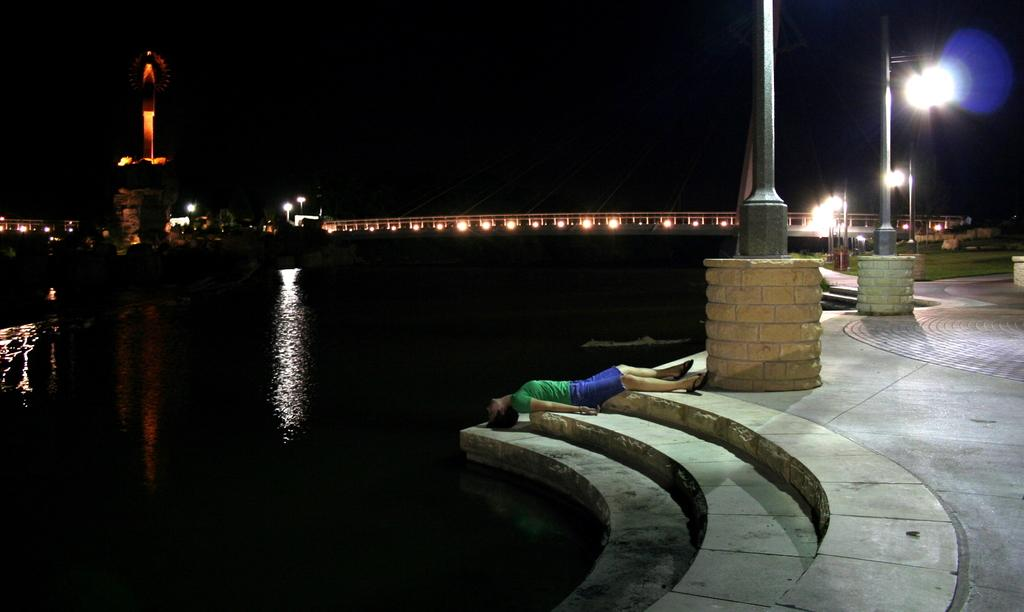What type of body of water is present in the image? There is a lake in the image. What type of surface can be seen near the lake? There is a pavement in the image. What architectural feature is present near the lake? There are stairs in the image. What objects are present near the stairs? There are poles in the image. What is the man in the image doing? The man is lying on the stairs. What can be seen in the background of the image? There are lights, a bridge, and a structure visible in the background. How many bears can be seen walking on the bridge in the image? There are no bears present in the image, and therefore no such activity can be observed. What type of sorting method is used for the lights in the background? There is no indication of a sorting method for the lights in the image; they are simply visible in the background. 